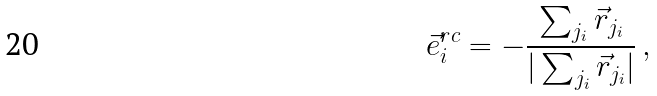Convert formula to latex. <formula><loc_0><loc_0><loc_500><loc_500>\vec { e } _ { i } ^ { r c } = - \frac { \sum _ { j _ { i } } \vec { r } _ { j _ { i } } } { | \sum _ { j _ { i } } \vec { r } _ { j _ { i } } | } \, ,</formula> 